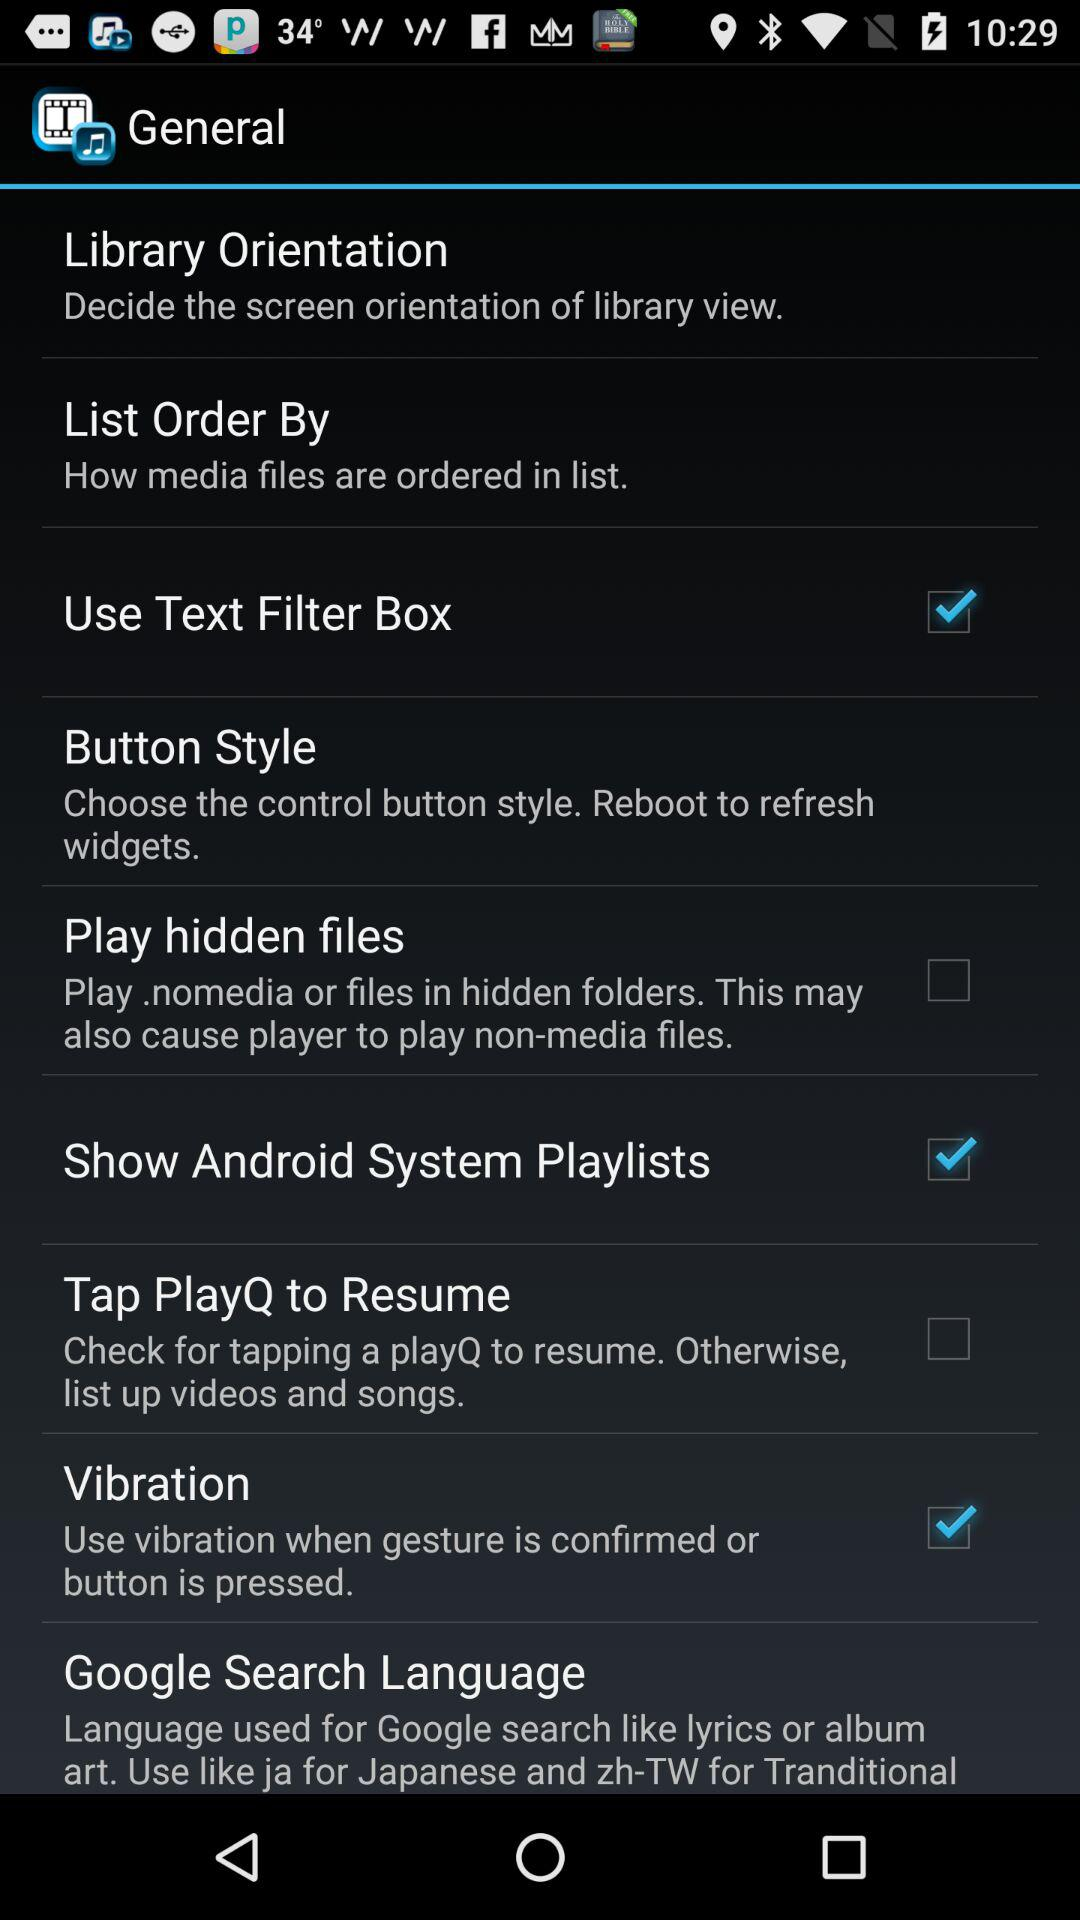What is the status of "Use Text Filter Box"? The status of "Use Text Filter Box" is "on". 